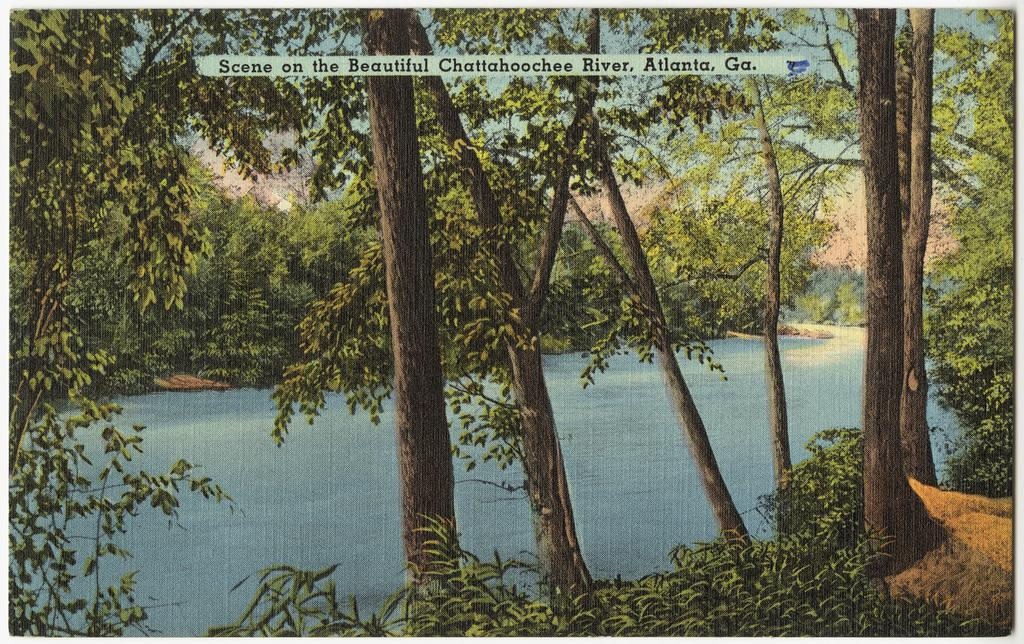What type of visual content is depicted in the image? The image appears to be a poster. What natural elements can be seen in the image? There are trees with branches and leaves, as well as a river with water flowing in the image. Can you describe the trees in the image? The trees have branches and leaves. What is the condition of the river in the image? The river has water flowing in it. What type of school apparatus can be seen in the image? There is no school apparatus present in the image. What part of the river is visible in the image? The image shows the river as a whole, not just a specific part. 